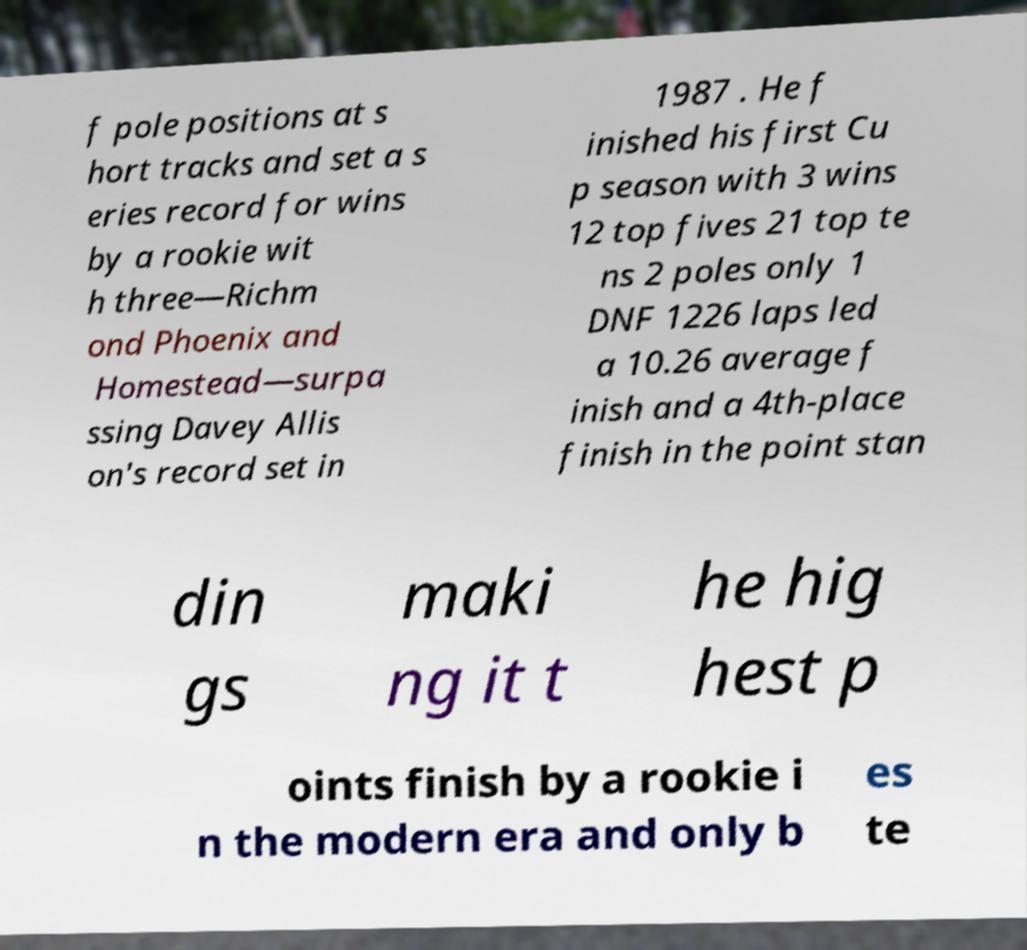Could you extract and type out the text from this image? f pole positions at s hort tracks and set a s eries record for wins by a rookie wit h three—Richm ond Phoenix and Homestead—surpa ssing Davey Allis on's record set in 1987 . He f inished his first Cu p season with 3 wins 12 top fives 21 top te ns 2 poles only 1 DNF 1226 laps led a 10.26 average f inish and a 4th-place finish in the point stan din gs maki ng it t he hig hest p oints finish by a rookie i n the modern era and only b es te 